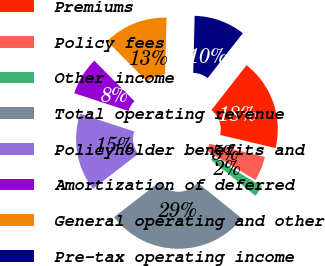Convert chart. <chart><loc_0><loc_0><loc_500><loc_500><pie_chart><fcel>Premiums<fcel>Policy fees<fcel>Other income<fcel>Total operating revenue<fcel>Policyholder benefits and<fcel>Amortization of deferred<fcel>General operating and other<fcel>Pre-tax operating income<nl><fcel>18.13%<fcel>4.88%<fcel>2.23%<fcel>28.73%<fcel>15.48%<fcel>7.53%<fcel>12.83%<fcel>10.18%<nl></chart> 